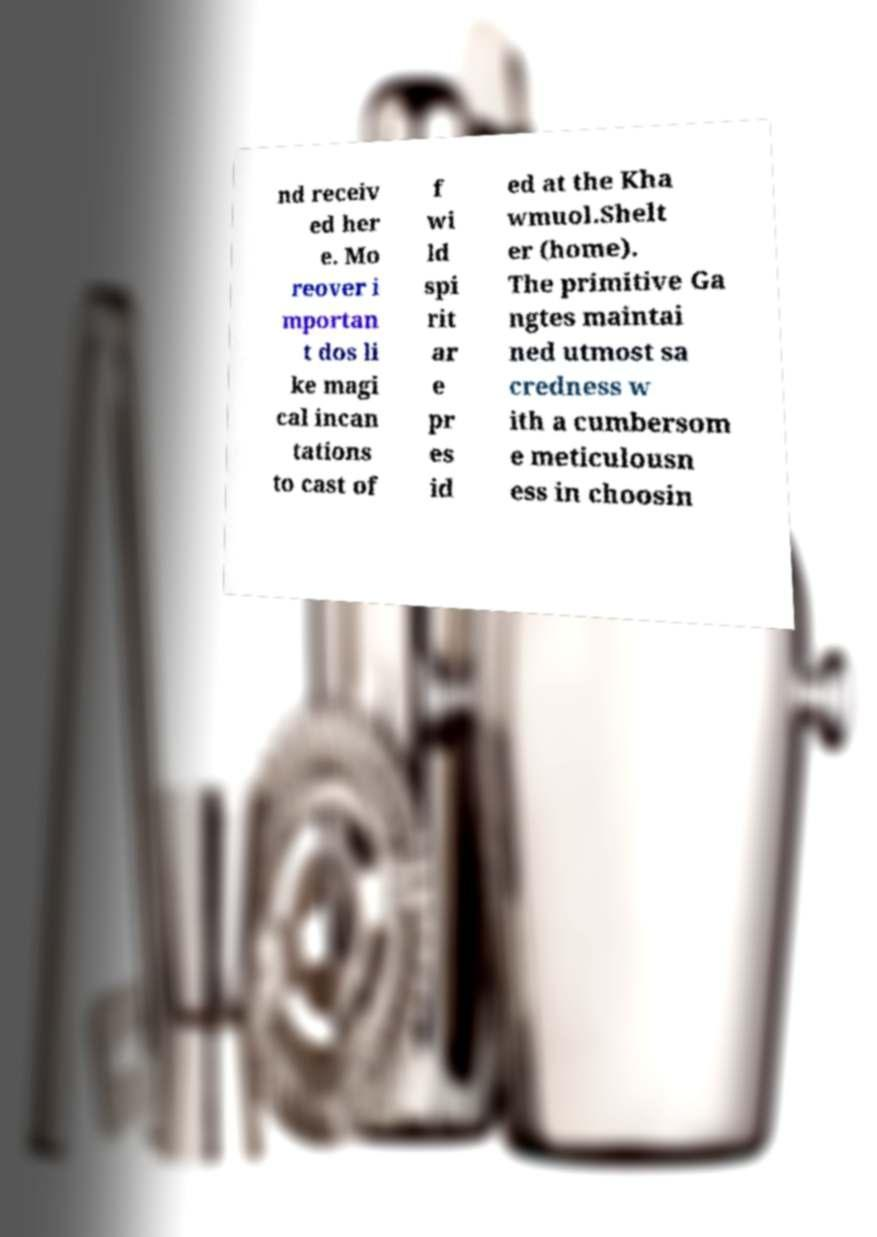Could you extract and type out the text from this image? nd receiv ed her e. Mo reover i mportan t dos li ke magi cal incan tations to cast of f wi ld spi rit ar e pr es id ed at the Kha wmuol.Shelt er (home). The primitive Ga ngtes maintai ned utmost sa credness w ith a cumbersom e meticulousn ess in choosin 